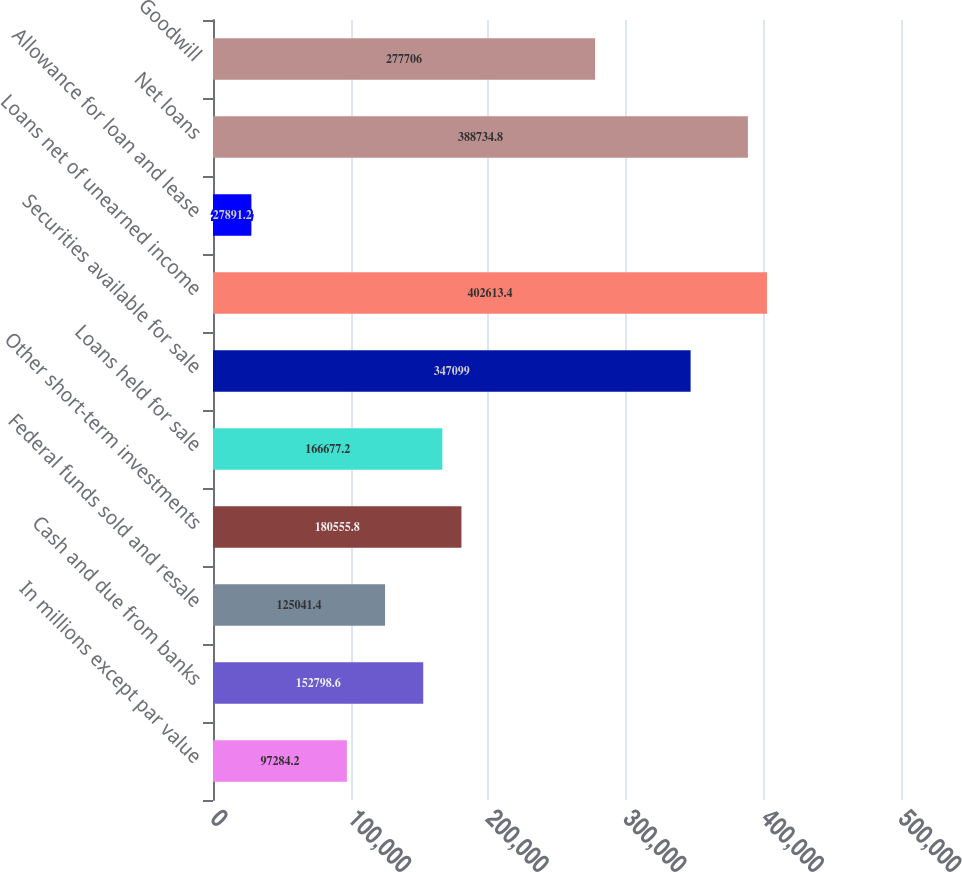<chart> <loc_0><loc_0><loc_500><loc_500><bar_chart><fcel>In millions except par value<fcel>Cash and due from banks<fcel>Federal funds sold and resale<fcel>Other short-term investments<fcel>Loans held for sale<fcel>Securities available for sale<fcel>Loans net of unearned income<fcel>Allowance for loan and lease<fcel>Net loans<fcel>Goodwill<nl><fcel>97284.2<fcel>152799<fcel>125041<fcel>180556<fcel>166677<fcel>347099<fcel>402613<fcel>27891.2<fcel>388735<fcel>277706<nl></chart> 